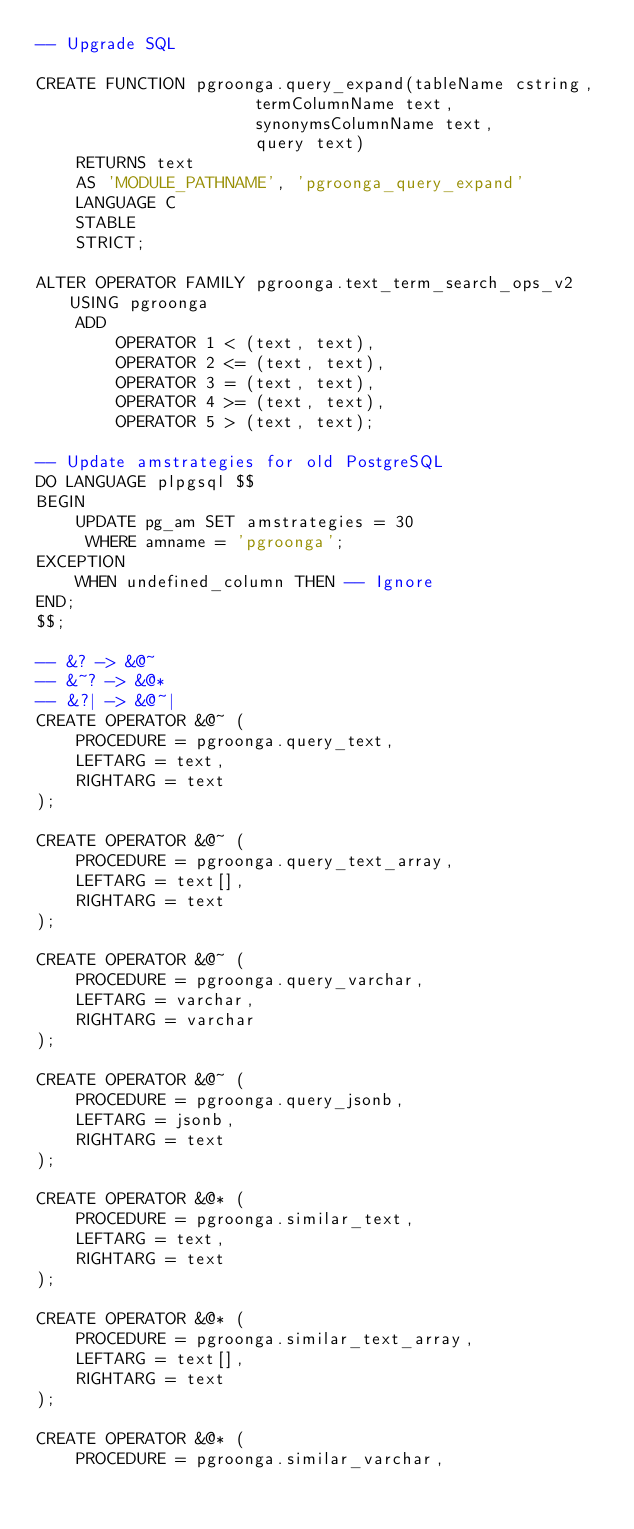Convert code to text. <code><loc_0><loc_0><loc_500><loc_500><_SQL_>-- Upgrade SQL

CREATE FUNCTION pgroonga.query_expand(tableName cstring,
				      termColumnName text,
				      synonymsColumnName text,
				      query text)
	RETURNS text
	AS 'MODULE_PATHNAME', 'pgroonga_query_expand'
	LANGUAGE C
	STABLE
	STRICT;

ALTER OPERATOR FAMILY pgroonga.text_term_search_ops_v2 USING pgroonga
	ADD
		OPERATOR 1 < (text, text),
		OPERATOR 2 <= (text, text),
		OPERATOR 3 = (text, text),
		OPERATOR 4 >= (text, text),
		OPERATOR 5 > (text, text);

-- Update amstrategies for old PostgreSQL
DO LANGUAGE plpgsql $$
BEGIN
	UPDATE pg_am SET amstrategies = 30
	 WHERE amname = 'pgroonga';
EXCEPTION
	WHEN undefined_column THEN -- Ignore
END;
$$;

-- &? -> &@~
-- &~? -> &@*
-- &?| -> &@~|
CREATE OPERATOR &@~ (
	PROCEDURE = pgroonga.query_text,
	LEFTARG = text,
	RIGHTARG = text
);

CREATE OPERATOR &@~ (
	PROCEDURE = pgroonga.query_text_array,
	LEFTARG = text[],
	RIGHTARG = text
);

CREATE OPERATOR &@~ (
	PROCEDURE = pgroonga.query_varchar,
	LEFTARG = varchar,
	RIGHTARG = varchar
);

CREATE OPERATOR &@~ (
	PROCEDURE = pgroonga.query_jsonb,
	LEFTARG = jsonb,
	RIGHTARG = text
);

CREATE OPERATOR &@* (
	PROCEDURE = pgroonga.similar_text,
	LEFTARG = text,
	RIGHTARG = text
);

CREATE OPERATOR &@* (
	PROCEDURE = pgroonga.similar_text_array,
	LEFTARG = text[],
	RIGHTARG = text
);

CREATE OPERATOR &@* (
	PROCEDURE = pgroonga.similar_varchar,</code> 